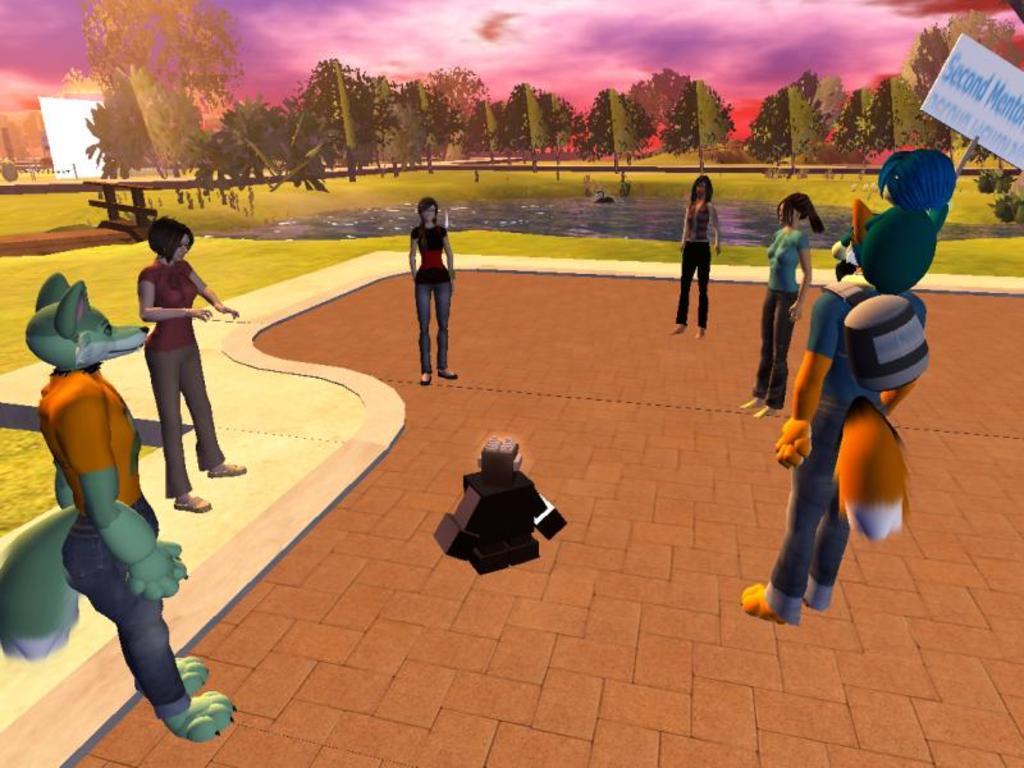Could you give a brief overview of what you see in this image? This picture is an animation picture. In this image there are group of people standing and at the bottom there is an object and there is a person holding the placard. At the back there are trees. At the top there are clouds. At the bottom there is grass and there is water. 